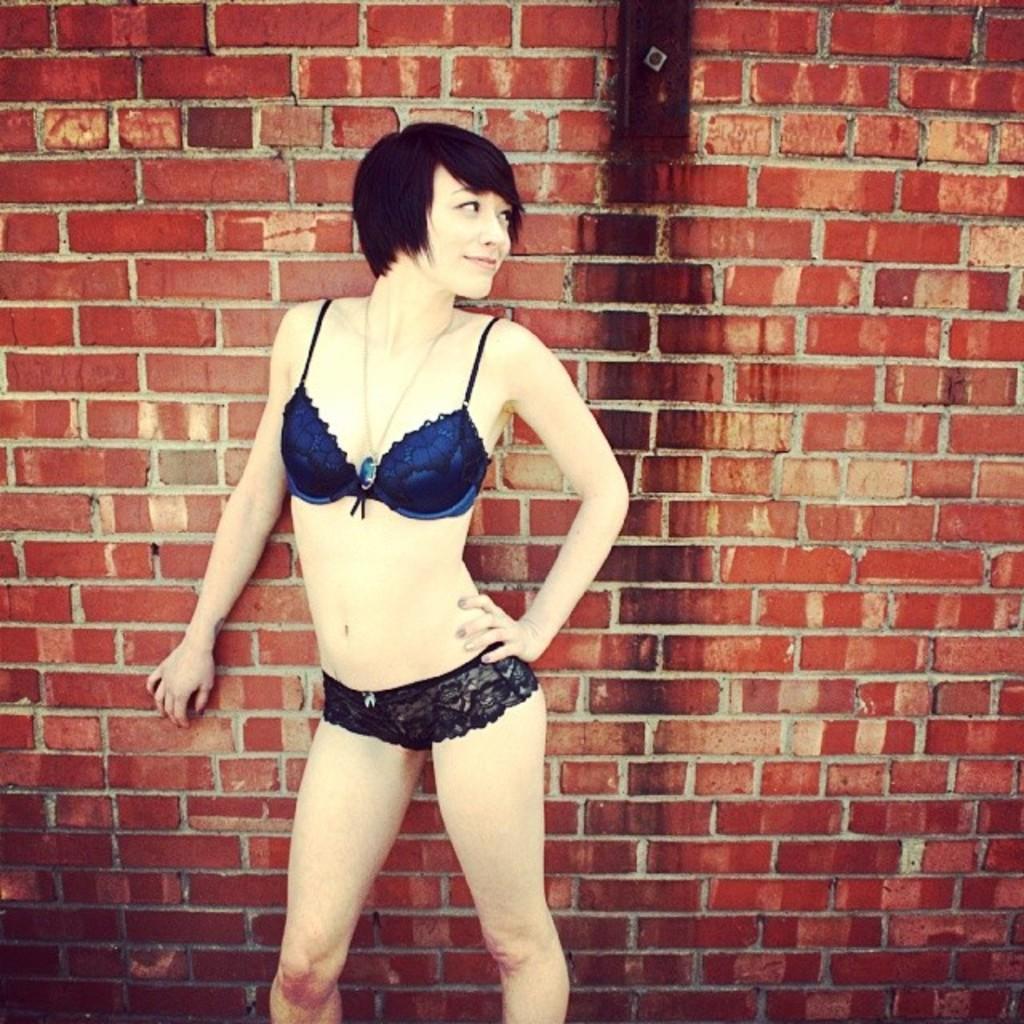Could you give a brief overview of what you see in this image? There is a woman standing. In the back there is a brick wall. 